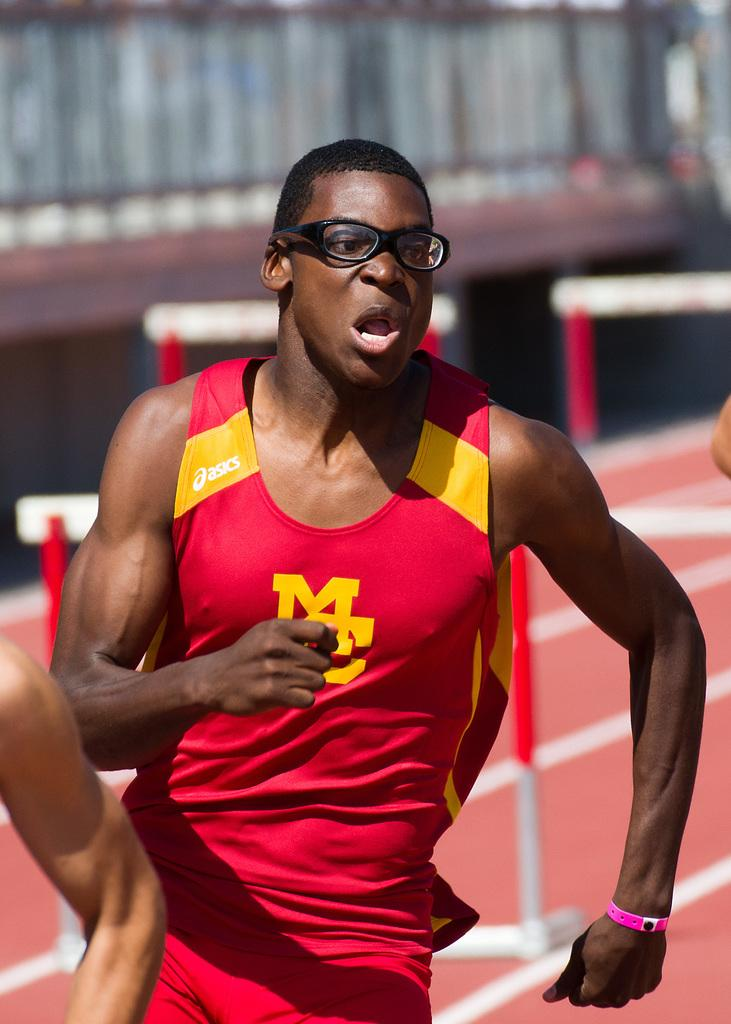Provide a one-sentence caption for the provided image. A man running track with the words MC on his shirt. 